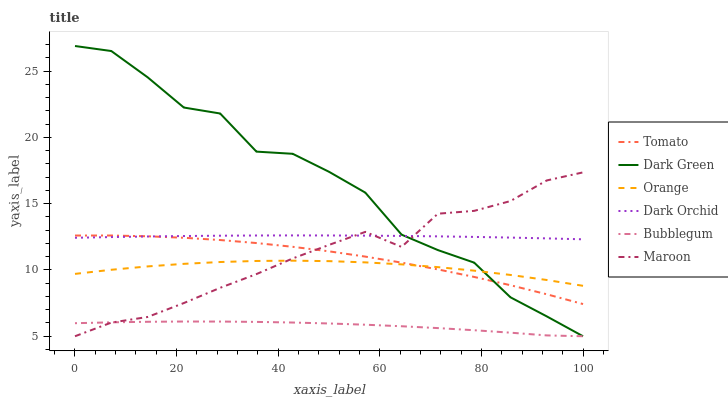Does Dark Orchid have the minimum area under the curve?
Answer yes or no. No. Does Dark Orchid have the maximum area under the curve?
Answer yes or no. No. Is Maroon the smoothest?
Answer yes or no. No. Is Maroon the roughest?
Answer yes or no. No. Does Dark Orchid have the lowest value?
Answer yes or no. No. Does Dark Orchid have the highest value?
Answer yes or no. No. Is Bubblegum less than Dark Orchid?
Answer yes or no. Yes. Is Tomato greater than Bubblegum?
Answer yes or no. Yes. Does Bubblegum intersect Dark Orchid?
Answer yes or no. No. 